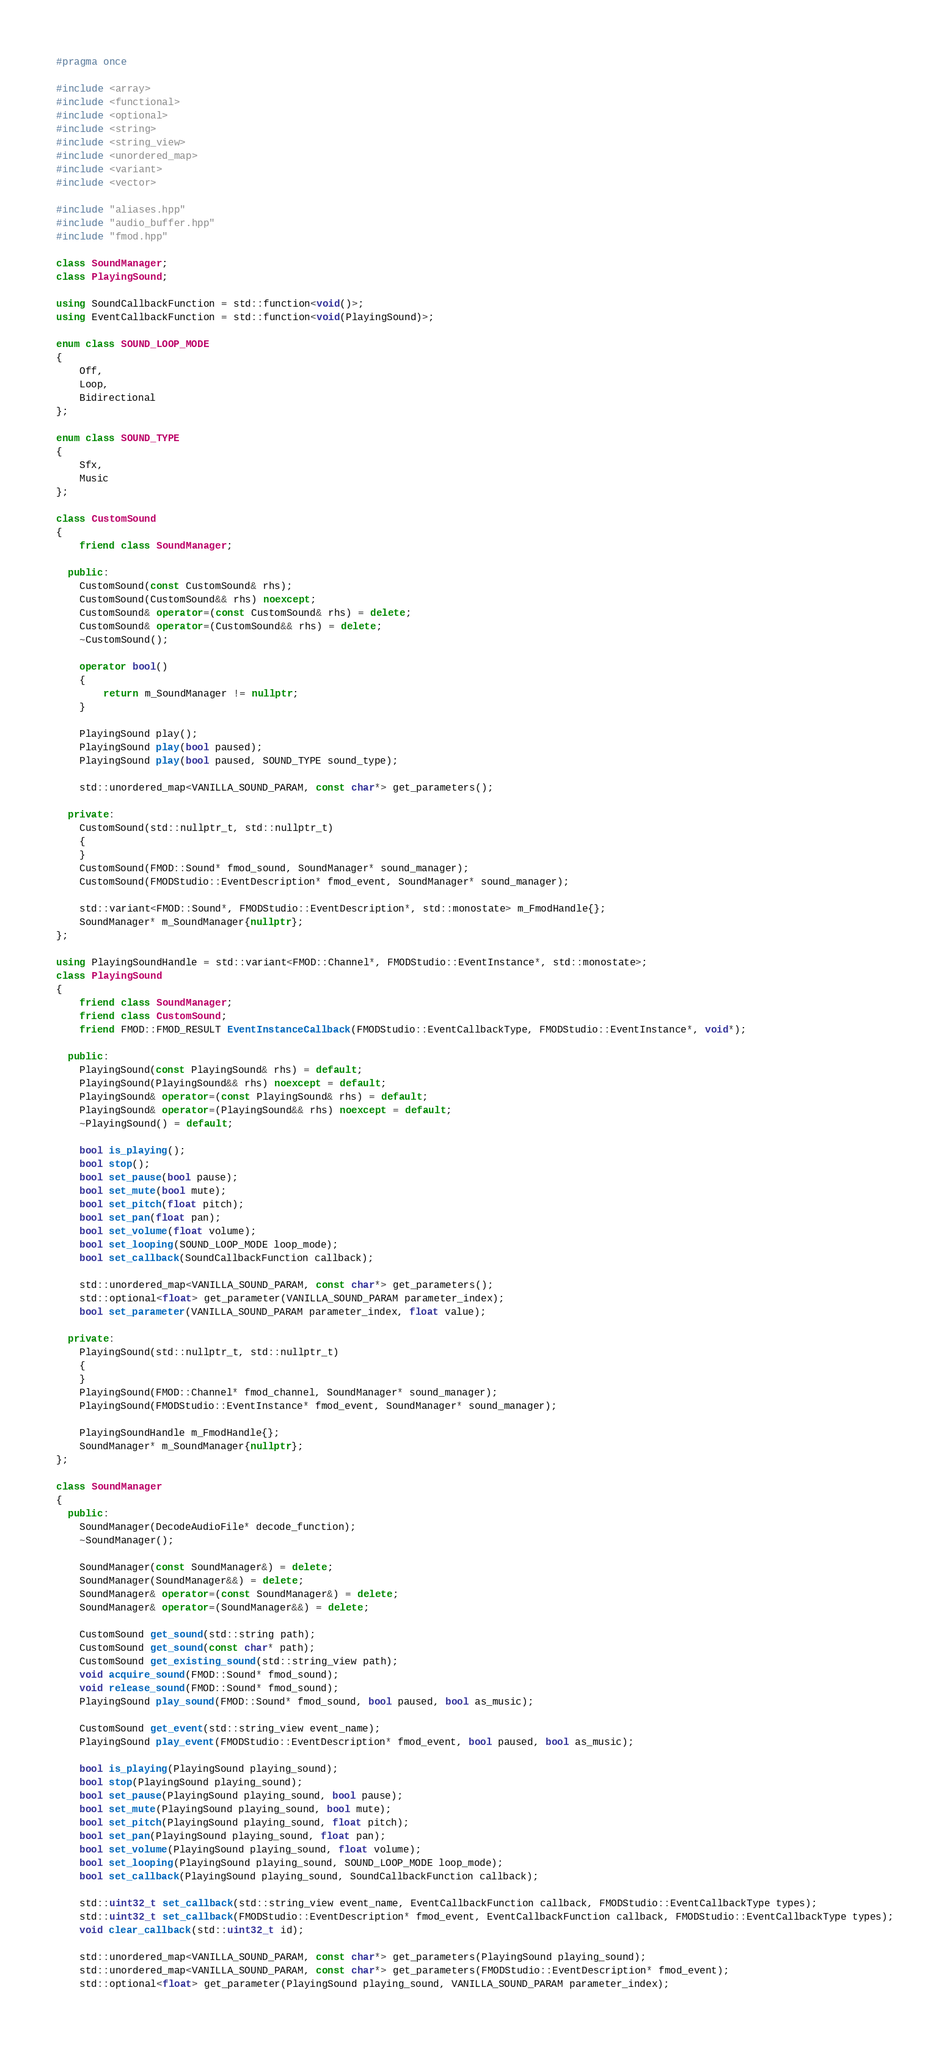<code> <loc_0><loc_0><loc_500><loc_500><_C++_>#pragma once

#include <array>
#include <functional>
#include <optional>
#include <string>
#include <string_view>
#include <unordered_map>
#include <variant>
#include <vector>

#include "aliases.hpp"
#include "audio_buffer.hpp"
#include "fmod.hpp"

class SoundManager;
class PlayingSound;

using SoundCallbackFunction = std::function<void()>;
using EventCallbackFunction = std::function<void(PlayingSound)>;

enum class SOUND_LOOP_MODE
{
    Off,
    Loop,
    Bidirectional
};

enum class SOUND_TYPE
{
    Sfx,
    Music
};

class CustomSound
{
    friend class SoundManager;

  public:
    CustomSound(const CustomSound& rhs);
    CustomSound(CustomSound&& rhs) noexcept;
    CustomSound& operator=(const CustomSound& rhs) = delete;
    CustomSound& operator=(CustomSound&& rhs) = delete;
    ~CustomSound();

    operator bool()
    {
        return m_SoundManager != nullptr;
    }

    PlayingSound play();
    PlayingSound play(bool paused);
    PlayingSound play(bool paused, SOUND_TYPE sound_type);

    std::unordered_map<VANILLA_SOUND_PARAM, const char*> get_parameters();

  private:
    CustomSound(std::nullptr_t, std::nullptr_t)
    {
    }
    CustomSound(FMOD::Sound* fmod_sound, SoundManager* sound_manager);
    CustomSound(FMODStudio::EventDescription* fmod_event, SoundManager* sound_manager);

    std::variant<FMOD::Sound*, FMODStudio::EventDescription*, std::monostate> m_FmodHandle{};
    SoundManager* m_SoundManager{nullptr};
};

using PlayingSoundHandle = std::variant<FMOD::Channel*, FMODStudio::EventInstance*, std::monostate>;
class PlayingSound
{
    friend class SoundManager;
    friend class CustomSound;
    friend FMOD::FMOD_RESULT EventInstanceCallback(FMODStudio::EventCallbackType, FMODStudio::EventInstance*, void*);

  public:
    PlayingSound(const PlayingSound& rhs) = default;
    PlayingSound(PlayingSound&& rhs) noexcept = default;
    PlayingSound& operator=(const PlayingSound& rhs) = default;
    PlayingSound& operator=(PlayingSound&& rhs) noexcept = default;
    ~PlayingSound() = default;

    bool is_playing();
    bool stop();
    bool set_pause(bool pause);
    bool set_mute(bool mute);
    bool set_pitch(float pitch);
    bool set_pan(float pan);
    bool set_volume(float volume);
    bool set_looping(SOUND_LOOP_MODE loop_mode);
    bool set_callback(SoundCallbackFunction callback);

    std::unordered_map<VANILLA_SOUND_PARAM, const char*> get_parameters();
    std::optional<float> get_parameter(VANILLA_SOUND_PARAM parameter_index);
    bool set_parameter(VANILLA_SOUND_PARAM parameter_index, float value);

  private:
    PlayingSound(std::nullptr_t, std::nullptr_t)
    {
    }
    PlayingSound(FMOD::Channel* fmod_channel, SoundManager* sound_manager);
    PlayingSound(FMODStudio::EventInstance* fmod_event, SoundManager* sound_manager);

    PlayingSoundHandle m_FmodHandle{};
    SoundManager* m_SoundManager{nullptr};
};

class SoundManager
{
  public:
    SoundManager(DecodeAudioFile* decode_function);
    ~SoundManager();

    SoundManager(const SoundManager&) = delete;
    SoundManager(SoundManager&&) = delete;
    SoundManager& operator=(const SoundManager&) = delete;
    SoundManager& operator=(SoundManager&&) = delete;

    CustomSound get_sound(std::string path);
    CustomSound get_sound(const char* path);
    CustomSound get_existing_sound(std::string_view path);
    void acquire_sound(FMOD::Sound* fmod_sound);
    void release_sound(FMOD::Sound* fmod_sound);
    PlayingSound play_sound(FMOD::Sound* fmod_sound, bool paused, bool as_music);

    CustomSound get_event(std::string_view event_name);
    PlayingSound play_event(FMODStudio::EventDescription* fmod_event, bool paused, bool as_music);

    bool is_playing(PlayingSound playing_sound);
    bool stop(PlayingSound playing_sound);
    bool set_pause(PlayingSound playing_sound, bool pause);
    bool set_mute(PlayingSound playing_sound, bool mute);
    bool set_pitch(PlayingSound playing_sound, float pitch);
    bool set_pan(PlayingSound playing_sound, float pan);
    bool set_volume(PlayingSound playing_sound, float volume);
    bool set_looping(PlayingSound playing_sound, SOUND_LOOP_MODE loop_mode);
    bool set_callback(PlayingSound playing_sound, SoundCallbackFunction callback);

    std::uint32_t set_callback(std::string_view event_name, EventCallbackFunction callback, FMODStudio::EventCallbackType types);
    std::uint32_t set_callback(FMODStudio::EventDescription* fmod_event, EventCallbackFunction callback, FMODStudio::EventCallbackType types);
    void clear_callback(std::uint32_t id);

    std::unordered_map<VANILLA_SOUND_PARAM, const char*> get_parameters(PlayingSound playing_sound);
    std::unordered_map<VANILLA_SOUND_PARAM, const char*> get_parameters(FMODStudio::EventDescription* fmod_event);
    std::optional<float> get_parameter(PlayingSound playing_sound, VANILLA_SOUND_PARAM parameter_index);</code> 